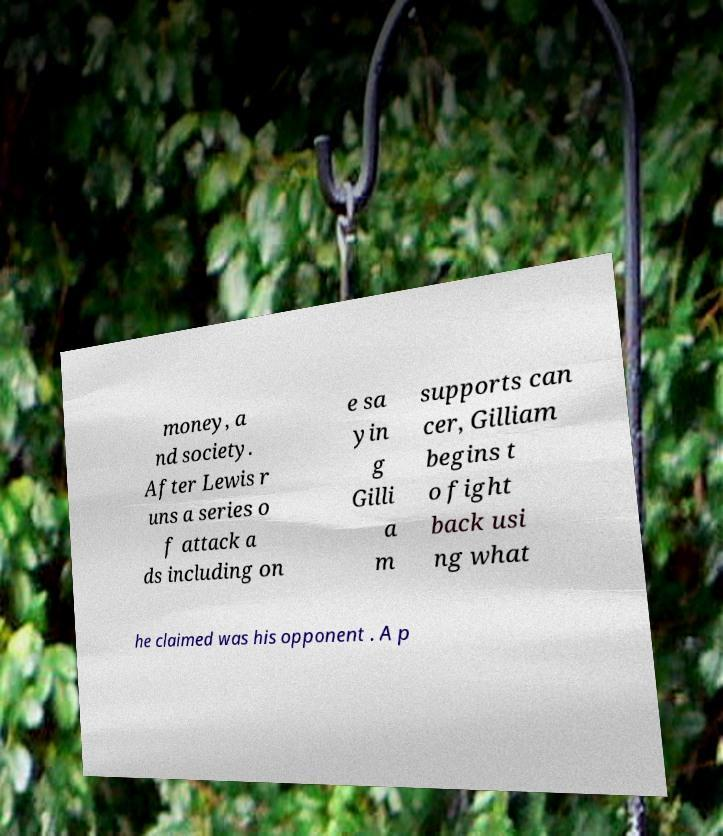There's text embedded in this image that I need extracted. Can you transcribe it verbatim? money, a nd society. After Lewis r uns a series o f attack a ds including on e sa yin g Gilli a m supports can cer, Gilliam begins t o fight back usi ng what he claimed was his opponent . A p 